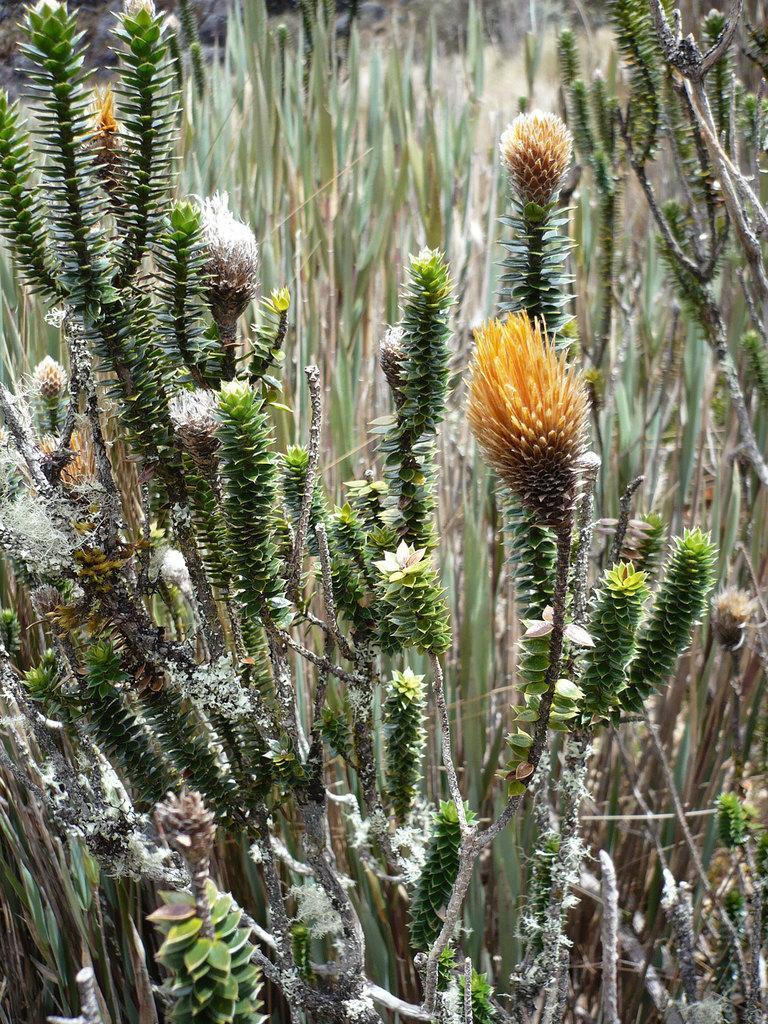How would you summarize this image in a sentence or two? In this image, I can see a plant with the branches, leaves and the flowers. I think this is the grass. 